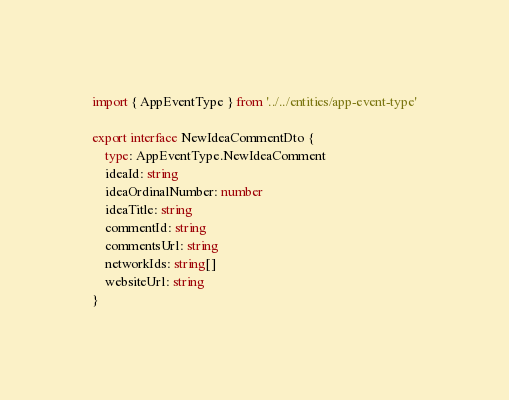<code> <loc_0><loc_0><loc_500><loc_500><_TypeScript_>import { AppEventType } from '../../entities/app-event-type'

export interface NewIdeaCommentDto {
    type: AppEventType.NewIdeaComment
    ideaId: string
    ideaOrdinalNumber: number
    ideaTitle: string
    commentId: string
    commentsUrl: string
    networkIds: string[]
    websiteUrl: string
}
</code> 